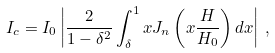<formula> <loc_0><loc_0><loc_500><loc_500>I _ { c } = I _ { 0 } \left | \frac { 2 } { 1 - \delta ^ { 2 } } \int _ { \delta } ^ { 1 } x J _ { n } \left ( x \frac { H } { H _ { 0 } } \right ) d x \right | \, ,</formula> 